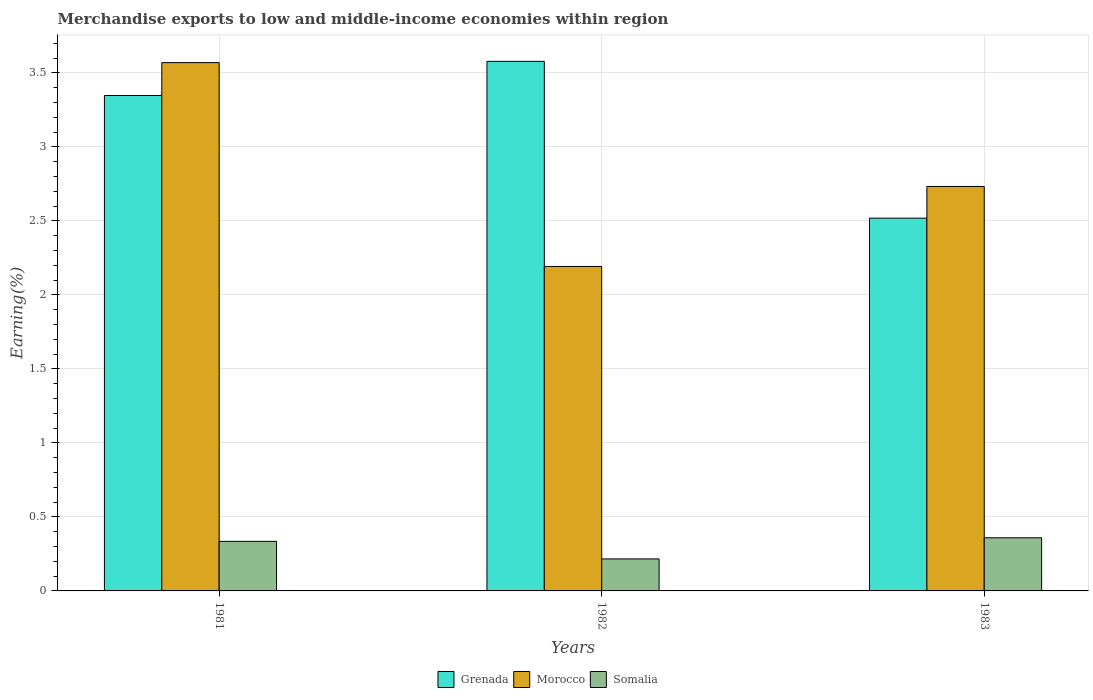How many different coloured bars are there?
Give a very brief answer. 3. Are the number of bars on each tick of the X-axis equal?
Offer a terse response. Yes. In how many cases, is the number of bars for a given year not equal to the number of legend labels?
Provide a short and direct response. 0. What is the percentage of amount earned from merchandise exports in Grenada in 1981?
Keep it short and to the point. 3.35. Across all years, what is the maximum percentage of amount earned from merchandise exports in Somalia?
Ensure brevity in your answer.  0.36. Across all years, what is the minimum percentage of amount earned from merchandise exports in Grenada?
Offer a very short reply. 2.52. What is the total percentage of amount earned from merchandise exports in Grenada in the graph?
Provide a succinct answer. 9.44. What is the difference between the percentage of amount earned from merchandise exports in Grenada in 1981 and that in 1982?
Provide a short and direct response. -0.23. What is the difference between the percentage of amount earned from merchandise exports in Morocco in 1982 and the percentage of amount earned from merchandise exports in Somalia in 1983?
Your response must be concise. 1.83. What is the average percentage of amount earned from merchandise exports in Grenada per year?
Make the answer very short. 3.15. In the year 1981, what is the difference between the percentage of amount earned from merchandise exports in Somalia and percentage of amount earned from merchandise exports in Morocco?
Provide a short and direct response. -3.23. What is the ratio of the percentage of amount earned from merchandise exports in Grenada in 1982 to that in 1983?
Keep it short and to the point. 1.42. Is the percentage of amount earned from merchandise exports in Morocco in 1982 less than that in 1983?
Provide a short and direct response. Yes. Is the difference between the percentage of amount earned from merchandise exports in Somalia in 1982 and 1983 greater than the difference between the percentage of amount earned from merchandise exports in Morocco in 1982 and 1983?
Your answer should be compact. Yes. What is the difference between the highest and the second highest percentage of amount earned from merchandise exports in Morocco?
Keep it short and to the point. 0.84. What is the difference between the highest and the lowest percentage of amount earned from merchandise exports in Grenada?
Your response must be concise. 1.06. In how many years, is the percentage of amount earned from merchandise exports in Somalia greater than the average percentage of amount earned from merchandise exports in Somalia taken over all years?
Your response must be concise. 2. Is the sum of the percentage of amount earned from merchandise exports in Morocco in 1982 and 1983 greater than the maximum percentage of amount earned from merchandise exports in Grenada across all years?
Your response must be concise. Yes. What does the 3rd bar from the left in 1982 represents?
Keep it short and to the point. Somalia. What does the 1st bar from the right in 1983 represents?
Your answer should be compact. Somalia. What is the difference between two consecutive major ticks on the Y-axis?
Offer a terse response. 0.5. Are the values on the major ticks of Y-axis written in scientific E-notation?
Make the answer very short. No. Does the graph contain any zero values?
Keep it short and to the point. No. Where does the legend appear in the graph?
Provide a short and direct response. Bottom center. How are the legend labels stacked?
Your response must be concise. Horizontal. What is the title of the graph?
Offer a very short reply. Merchandise exports to low and middle-income economies within region. What is the label or title of the Y-axis?
Offer a very short reply. Earning(%). What is the Earning(%) of Grenada in 1981?
Offer a terse response. 3.35. What is the Earning(%) in Morocco in 1981?
Your answer should be compact. 3.57. What is the Earning(%) of Somalia in 1981?
Your answer should be very brief. 0.33. What is the Earning(%) in Grenada in 1982?
Your response must be concise. 3.58. What is the Earning(%) in Morocco in 1982?
Ensure brevity in your answer.  2.19. What is the Earning(%) in Somalia in 1982?
Make the answer very short. 0.22. What is the Earning(%) in Grenada in 1983?
Ensure brevity in your answer.  2.52. What is the Earning(%) in Morocco in 1983?
Offer a very short reply. 2.73. What is the Earning(%) of Somalia in 1983?
Your answer should be compact. 0.36. Across all years, what is the maximum Earning(%) in Grenada?
Give a very brief answer. 3.58. Across all years, what is the maximum Earning(%) in Morocco?
Your answer should be very brief. 3.57. Across all years, what is the maximum Earning(%) in Somalia?
Provide a succinct answer. 0.36. Across all years, what is the minimum Earning(%) in Grenada?
Provide a succinct answer. 2.52. Across all years, what is the minimum Earning(%) in Morocco?
Give a very brief answer. 2.19. Across all years, what is the minimum Earning(%) in Somalia?
Your answer should be compact. 0.22. What is the total Earning(%) of Grenada in the graph?
Provide a short and direct response. 9.44. What is the total Earning(%) of Morocco in the graph?
Provide a succinct answer. 8.49. What is the total Earning(%) of Somalia in the graph?
Provide a short and direct response. 0.91. What is the difference between the Earning(%) of Grenada in 1981 and that in 1982?
Offer a very short reply. -0.23. What is the difference between the Earning(%) of Morocco in 1981 and that in 1982?
Your response must be concise. 1.38. What is the difference between the Earning(%) in Somalia in 1981 and that in 1982?
Provide a short and direct response. 0.12. What is the difference between the Earning(%) of Grenada in 1981 and that in 1983?
Offer a very short reply. 0.83. What is the difference between the Earning(%) in Morocco in 1981 and that in 1983?
Offer a very short reply. 0.84. What is the difference between the Earning(%) in Somalia in 1981 and that in 1983?
Ensure brevity in your answer.  -0.02. What is the difference between the Earning(%) in Grenada in 1982 and that in 1983?
Keep it short and to the point. 1.06. What is the difference between the Earning(%) of Morocco in 1982 and that in 1983?
Make the answer very short. -0.54. What is the difference between the Earning(%) in Somalia in 1982 and that in 1983?
Give a very brief answer. -0.14. What is the difference between the Earning(%) of Grenada in 1981 and the Earning(%) of Morocco in 1982?
Your answer should be very brief. 1.15. What is the difference between the Earning(%) of Grenada in 1981 and the Earning(%) of Somalia in 1982?
Give a very brief answer. 3.13. What is the difference between the Earning(%) in Morocco in 1981 and the Earning(%) in Somalia in 1982?
Offer a terse response. 3.35. What is the difference between the Earning(%) of Grenada in 1981 and the Earning(%) of Morocco in 1983?
Keep it short and to the point. 0.61. What is the difference between the Earning(%) in Grenada in 1981 and the Earning(%) in Somalia in 1983?
Your answer should be compact. 2.99. What is the difference between the Earning(%) in Morocco in 1981 and the Earning(%) in Somalia in 1983?
Ensure brevity in your answer.  3.21. What is the difference between the Earning(%) of Grenada in 1982 and the Earning(%) of Morocco in 1983?
Your answer should be compact. 0.85. What is the difference between the Earning(%) in Grenada in 1982 and the Earning(%) in Somalia in 1983?
Provide a succinct answer. 3.22. What is the difference between the Earning(%) of Morocco in 1982 and the Earning(%) of Somalia in 1983?
Offer a terse response. 1.83. What is the average Earning(%) in Grenada per year?
Offer a terse response. 3.15. What is the average Earning(%) of Morocco per year?
Your answer should be compact. 2.83. What is the average Earning(%) in Somalia per year?
Your response must be concise. 0.3. In the year 1981, what is the difference between the Earning(%) in Grenada and Earning(%) in Morocco?
Offer a terse response. -0.22. In the year 1981, what is the difference between the Earning(%) of Grenada and Earning(%) of Somalia?
Ensure brevity in your answer.  3.01. In the year 1981, what is the difference between the Earning(%) of Morocco and Earning(%) of Somalia?
Provide a succinct answer. 3.23. In the year 1982, what is the difference between the Earning(%) in Grenada and Earning(%) in Morocco?
Your response must be concise. 1.39. In the year 1982, what is the difference between the Earning(%) in Grenada and Earning(%) in Somalia?
Ensure brevity in your answer.  3.36. In the year 1982, what is the difference between the Earning(%) in Morocco and Earning(%) in Somalia?
Your response must be concise. 1.98. In the year 1983, what is the difference between the Earning(%) of Grenada and Earning(%) of Morocco?
Provide a short and direct response. -0.21. In the year 1983, what is the difference between the Earning(%) of Grenada and Earning(%) of Somalia?
Offer a terse response. 2.16. In the year 1983, what is the difference between the Earning(%) of Morocco and Earning(%) of Somalia?
Offer a terse response. 2.37. What is the ratio of the Earning(%) in Grenada in 1981 to that in 1982?
Your answer should be compact. 0.94. What is the ratio of the Earning(%) of Morocco in 1981 to that in 1982?
Offer a terse response. 1.63. What is the ratio of the Earning(%) in Somalia in 1981 to that in 1982?
Keep it short and to the point. 1.55. What is the ratio of the Earning(%) of Grenada in 1981 to that in 1983?
Provide a short and direct response. 1.33. What is the ratio of the Earning(%) in Morocco in 1981 to that in 1983?
Your response must be concise. 1.31. What is the ratio of the Earning(%) of Somalia in 1981 to that in 1983?
Provide a succinct answer. 0.93. What is the ratio of the Earning(%) in Grenada in 1982 to that in 1983?
Provide a short and direct response. 1.42. What is the ratio of the Earning(%) of Morocco in 1982 to that in 1983?
Provide a short and direct response. 0.8. What is the ratio of the Earning(%) in Somalia in 1982 to that in 1983?
Offer a very short reply. 0.6. What is the difference between the highest and the second highest Earning(%) in Grenada?
Provide a short and direct response. 0.23. What is the difference between the highest and the second highest Earning(%) of Morocco?
Make the answer very short. 0.84. What is the difference between the highest and the second highest Earning(%) of Somalia?
Your answer should be compact. 0.02. What is the difference between the highest and the lowest Earning(%) in Grenada?
Provide a succinct answer. 1.06. What is the difference between the highest and the lowest Earning(%) in Morocco?
Keep it short and to the point. 1.38. What is the difference between the highest and the lowest Earning(%) in Somalia?
Keep it short and to the point. 0.14. 